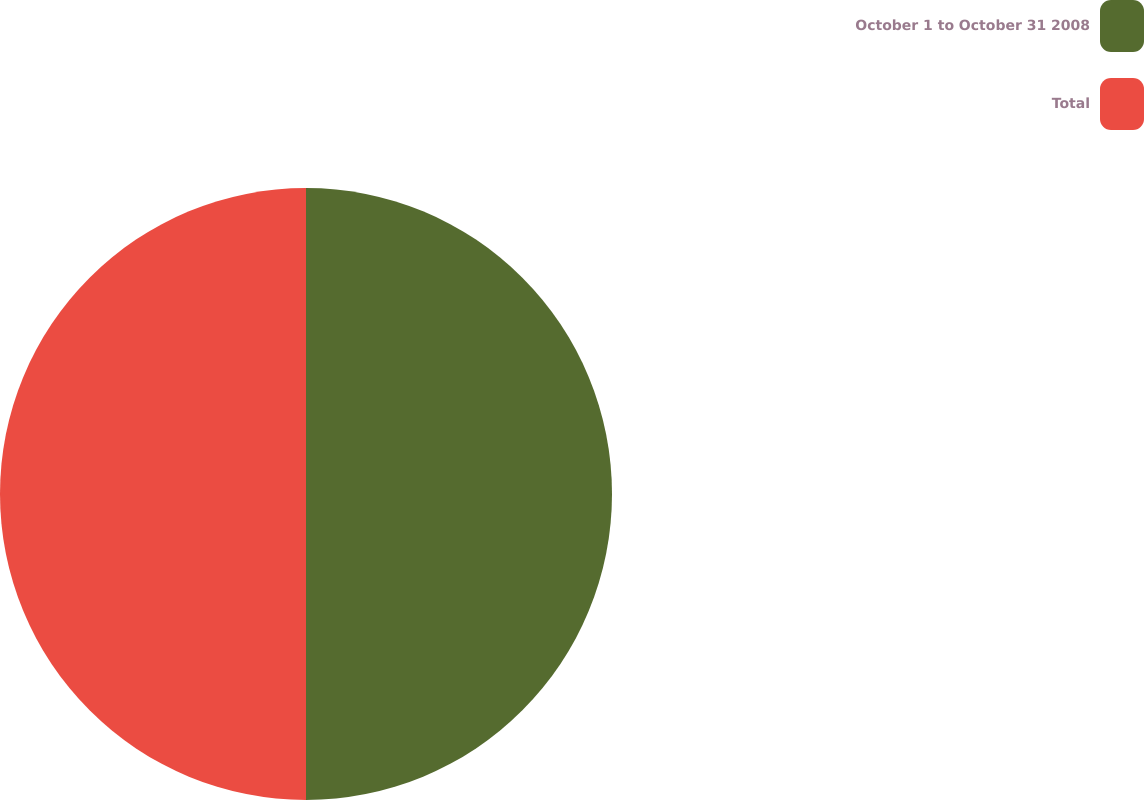<chart> <loc_0><loc_0><loc_500><loc_500><pie_chart><fcel>October 1 to October 31 2008<fcel>Total<nl><fcel>50.0%<fcel>50.0%<nl></chart> 